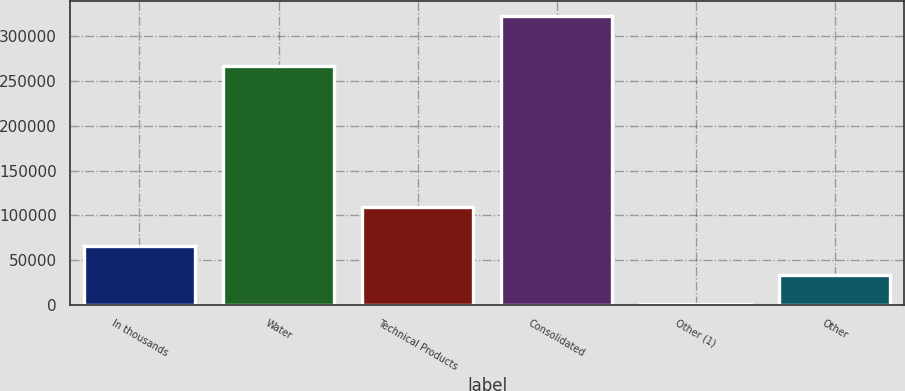Convert chart. <chart><loc_0><loc_0><loc_500><loc_500><bar_chart><fcel>In thousands<fcel>Water<fcel>Technical Products<fcel>Consolidated<fcel>Other (1)<fcel>Other<nl><fcel>65738.4<fcel>267138<fcel>109229<fcel>323072<fcel>1405<fcel>33571.7<nl></chart> 